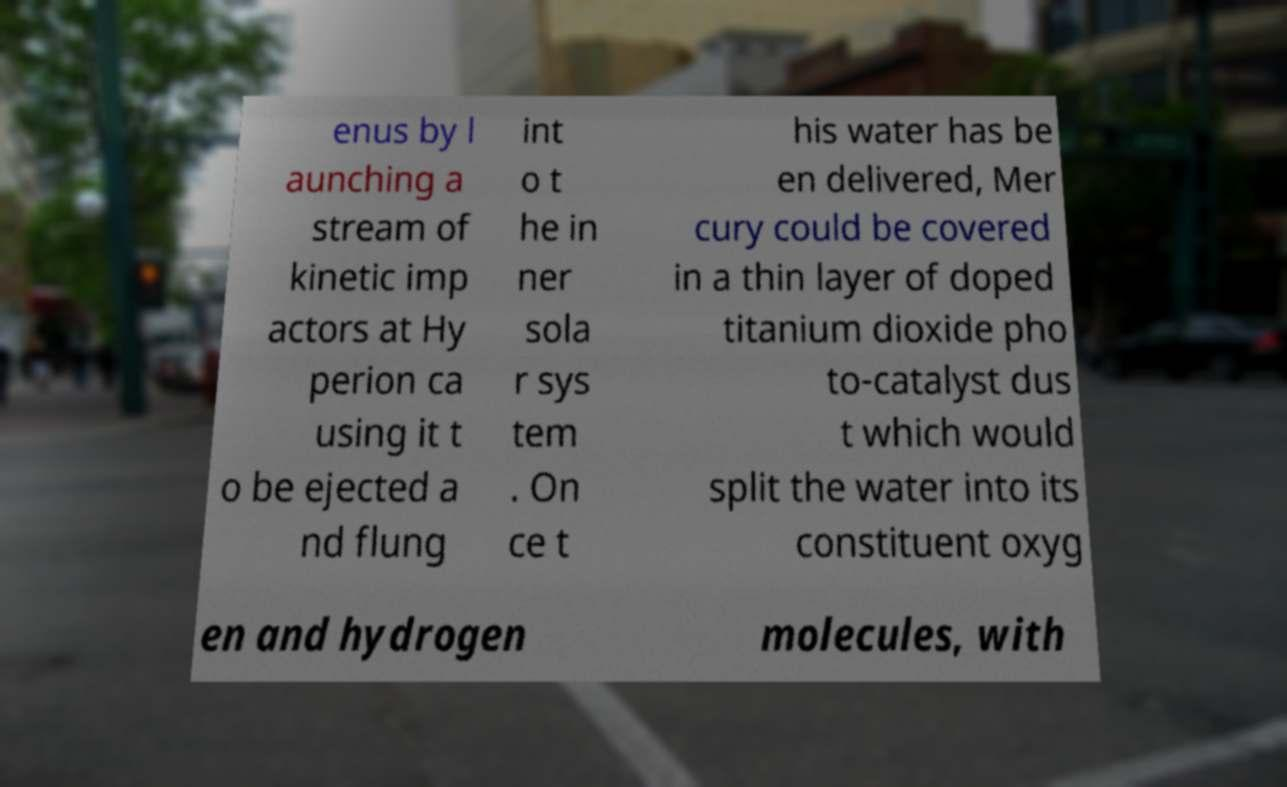Can you accurately transcribe the text from the provided image for me? enus by l aunching a stream of kinetic imp actors at Hy perion ca using it t o be ejected a nd flung int o t he in ner sola r sys tem . On ce t his water has be en delivered, Mer cury could be covered in a thin layer of doped titanium dioxide pho to-catalyst dus t which would split the water into its constituent oxyg en and hydrogen molecules, with 